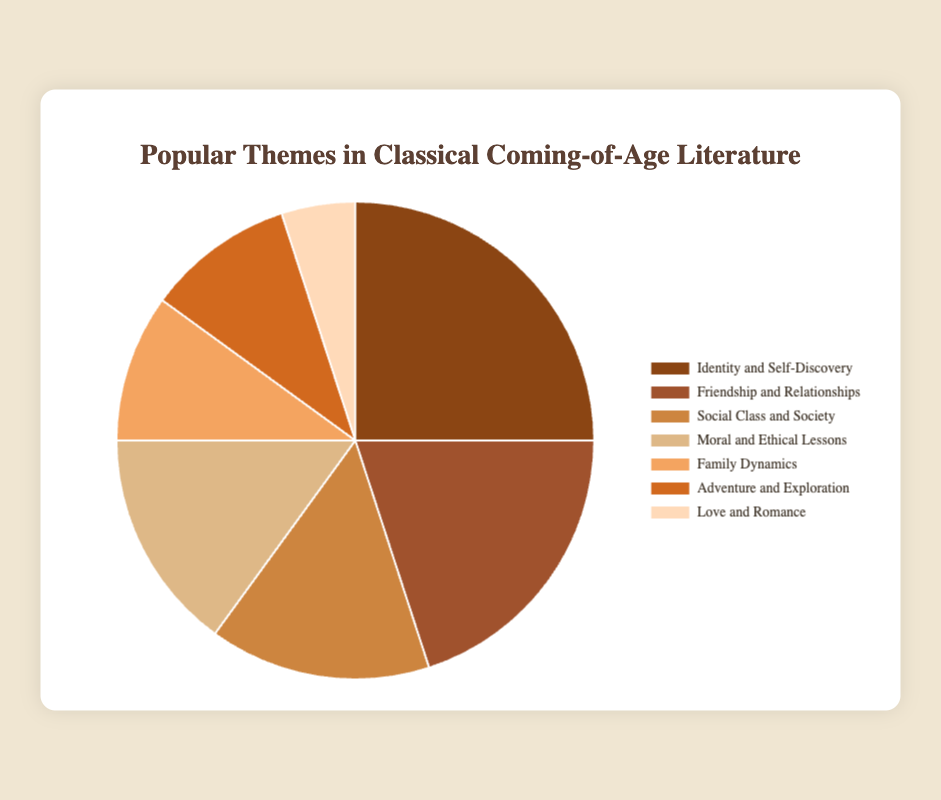What is the most popular theme in classical coming-of-age literature? The pie chart shows the distribution of various themes in percentages. The theme with the highest percentage is the most popular. The theme "Identity and Self-Discovery" has the highest percentage at 25%.
Answer: Identity and Self-Discovery How much more popular is "Identity and Self-Discovery" compared to "Love and Romance"? From the chart, "Identity and Self-Discovery" is at 25%, and "Love and Romance" is at 5%. The difference is 25% - 5%.
Answer: 20% Which themes are equally popular according to the reader surveys? The pie chart distribution shows percentages for all themes. "Social Class and Society" and "Moral and Ethical Lessons" each have the same percentage of 15%.
Answer: Social Class and Society, and Moral and Ethical Lessons What is the combined percentage of themes related to "Friendship and Relationships" and "Family Dynamics"? The chart shows "Friendship and Relationships" at 20% and "Family Dynamics" at 10%. Adding these percentages, 20% + 10% = 30%.
Answer: 30% Which theme appears less frequently than "Social Class and Society" but more frequently than "Love and Romance"? Observing the percentages, "Social Class and Society" is at 15%. The themes between 15% and 5% are "Family Dynamics" and "Adventure and Exploration," both at 10%.
Answer: Family Dynamics and Adventure and Exploration By what factor is "Moral and Ethical Lessons" more popular than "Love and Romance"? The chart shows "Moral and Ethical Lessons" at 15% and "Love and Romance" at 5%. The factor of popularity is 15% / 5%.
Answer: 3 times What percentage of the themes are related to human relationships (including Friendship and Relationships, and Love and Romance)? Summing "Friendship and Relationships" at 20% and "Love and Romance" at 5%, we get 20% + 5% = 25%.
Answer: 25% Which three themes together constitute exactly half (50%) of the total themes? Using the chart, we combine different themes and check their total. The themes "Identity and Self-Discovery" (25%), "Friendship and Relationships" (20%), and "Love and Romance" (5%) total 25% + 20% + 5% = 50%.
Answer: Identity and Self-Discovery, Friendship and Relationships, and Love and Romance What is the visual color associated with the "Adventure and Exploration" theme? Looking at the pie chart's legend, each theme is associated with a specific color. "Adventure and Exploration" is the sixth segment from the top and is colored brownish with a lighter shade.
Answer: Brownish with a lighter shade 